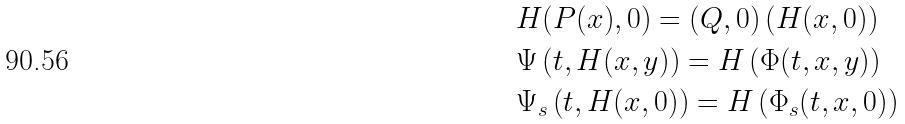Convert formula to latex. <formula><loc_0><loc_0><loc_500><loc_500>& H ( P ( x ) , 0 ) = ( Q , 0 ) \left ( H ( x , 0 ) \right ) \\ & \Psi \left ( t , H ( x , y ) \right ) = H \left ( \Phi ( t , x , y ) \right ) \\ & \Psi _ { s } \left ( t , H ( x , 0 ) \right ) = H \left ( \Phi _ { s } ( t , x , 0 ) \right )</formula> 